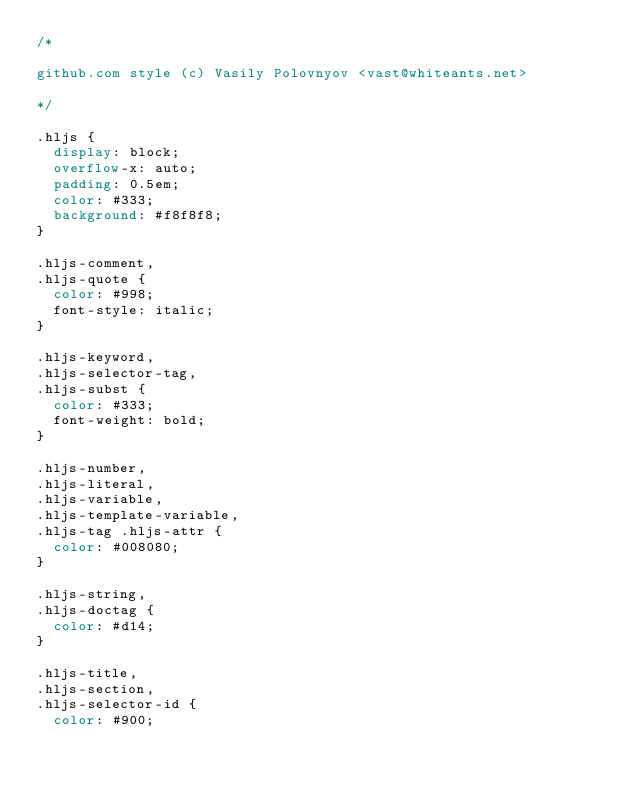<code> <loc_0><loc_0><loc_500><loc_500><_CSS_>/*

github.com style (c) Vasily Polovnyov <vast@whiteants.net>

*/

.hljs {
	display: block;
	overflow-x: auto;
	padding: 0.5em;
	color: #333;
	background: #f8f8f8;
}

.hljs-comment,
.hljs-quote {
	color: #998;
	font-style: italic;
}

.hljs-keyword,
.hljs-selector-tag,
.hljs-subst {
	color: #333;
	font-weight: bold;
}

.hljs-number,
.hljs-literal,
.hljs-variable,
.hljs-template-variable,
.hljs-tag .hljs-attr {
	color: #008080;
}

.hljs-string,
.hljs-doctag {
	color: #d14;
}

.hljs-title,
.hljs-section,
.hljs-selector-id {
	color: #900;</code> 